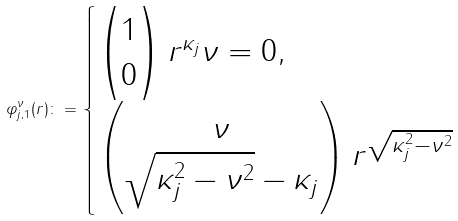Convert formula to latex. <formula><loc_0><loc_0><loc_500><loc_500>\varphi ^ { \nu } _ { j , 1 } ( r ) \colon = \begin{cases} \begin{pmatrix} 1 \\ 0 \end{pmatrix} r ^ { \kappa _ { j } } \nu = 0 , \\ \begin{pmatrix} \nu \\ \sqrt { \kappa _ { j } ^ { 2 } - \nu ^ { 2 } } - \kappa _ { j } \end{pmatrix} r ^ { \sqrt { \kappa _ { j } ^ { 2 } - \nu ^ { 2 } } } \end{cases}</formula> 